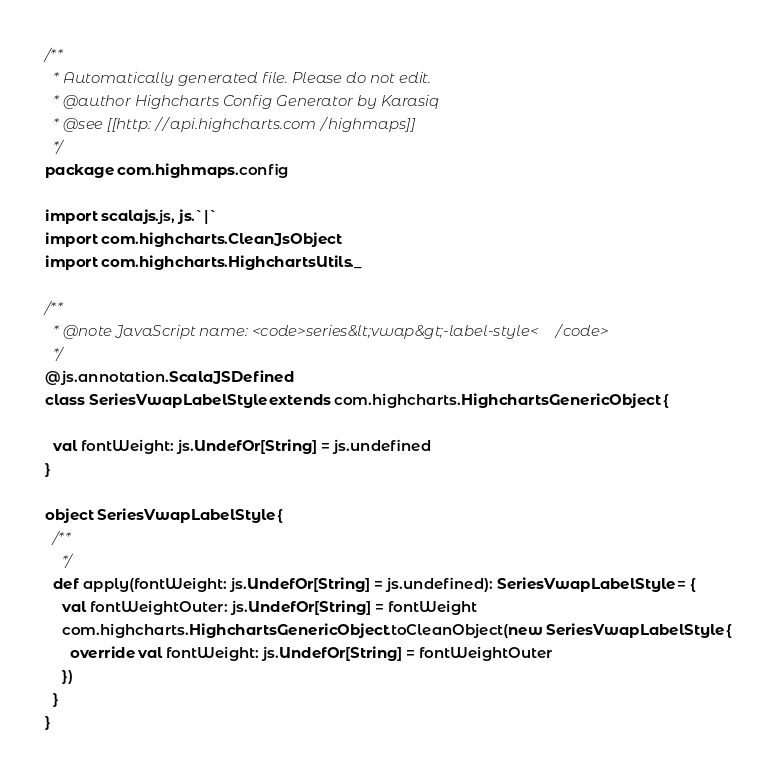Convert code to text. <code><loc_0><loc_0><loc_500><loc_500><_Scala_>/**
  * Automatically generated file. Please do not edit.
  * @author Highcharts Config Generator by Karasiq
  * @see [[http://api.highcharts.com/highmaps]]
  */
package com.highmaps.config

import scalajs.js, js.`|`
import com.highcharts.CleanJsObject
import com.highcharts.HighchartsUtils._

/**
  * @note JavaScript name: <code>series&lt;vwap&gt;-label-style</code>
  */
@js.annotation.ScalaJSDefined
class SeriesVwapLabelStyle extends com.highcharts.HighchartsGenericObject {

  val fontWeight: js.UndefOr[String] = js.undefined
}

object SeriesVwapLabelStyle {
  /**
    */
  def apply(fontWeight: js.UndefOr[String] = js.undefined): SeriesVwapLabelStyle = {
    val fontWeightOuter: js.UndefOr[String] = fontWeight
    com.highcharts.HighchartsGenericObject.toCleanObject(new SeriesVwapLabelStyle {
      override val fontWeight: js.UndefOr[String] = fontWeightOuter
    })
  }
}
</code> 